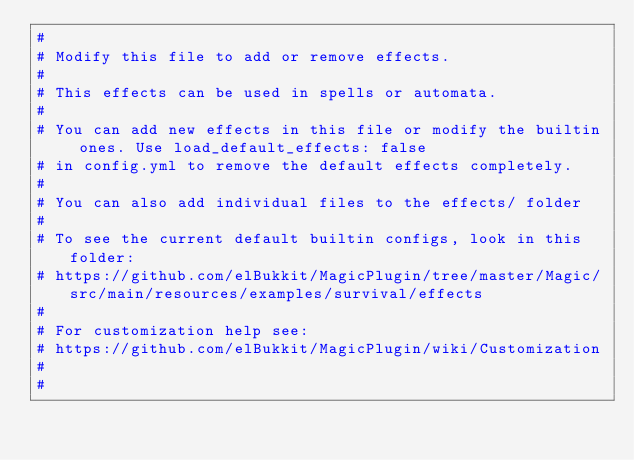<code> <loc_0><loc_0><loc_500><loc_500><_YAML_>#
# Modify this file to add or remove effects.
#
# This effects can be used in spells or automata.
#
# You can add new effects in this file or modify the builtin ones. Use load_default_effects: false
# in config.yml to remove the default effects completely.
#
# You can also add individual files to the effects/ folder
#
# To see the current default builtin configs, look in this folder:
# https://github.com/elBukkit/MagicPlugin/tree/master/Magic/src/main/resources/examples/survival/effects
#
# For customization help see:
# https://github.com/elBukkit/MagicPlugin/wiki/Customization
#
#
</code> 